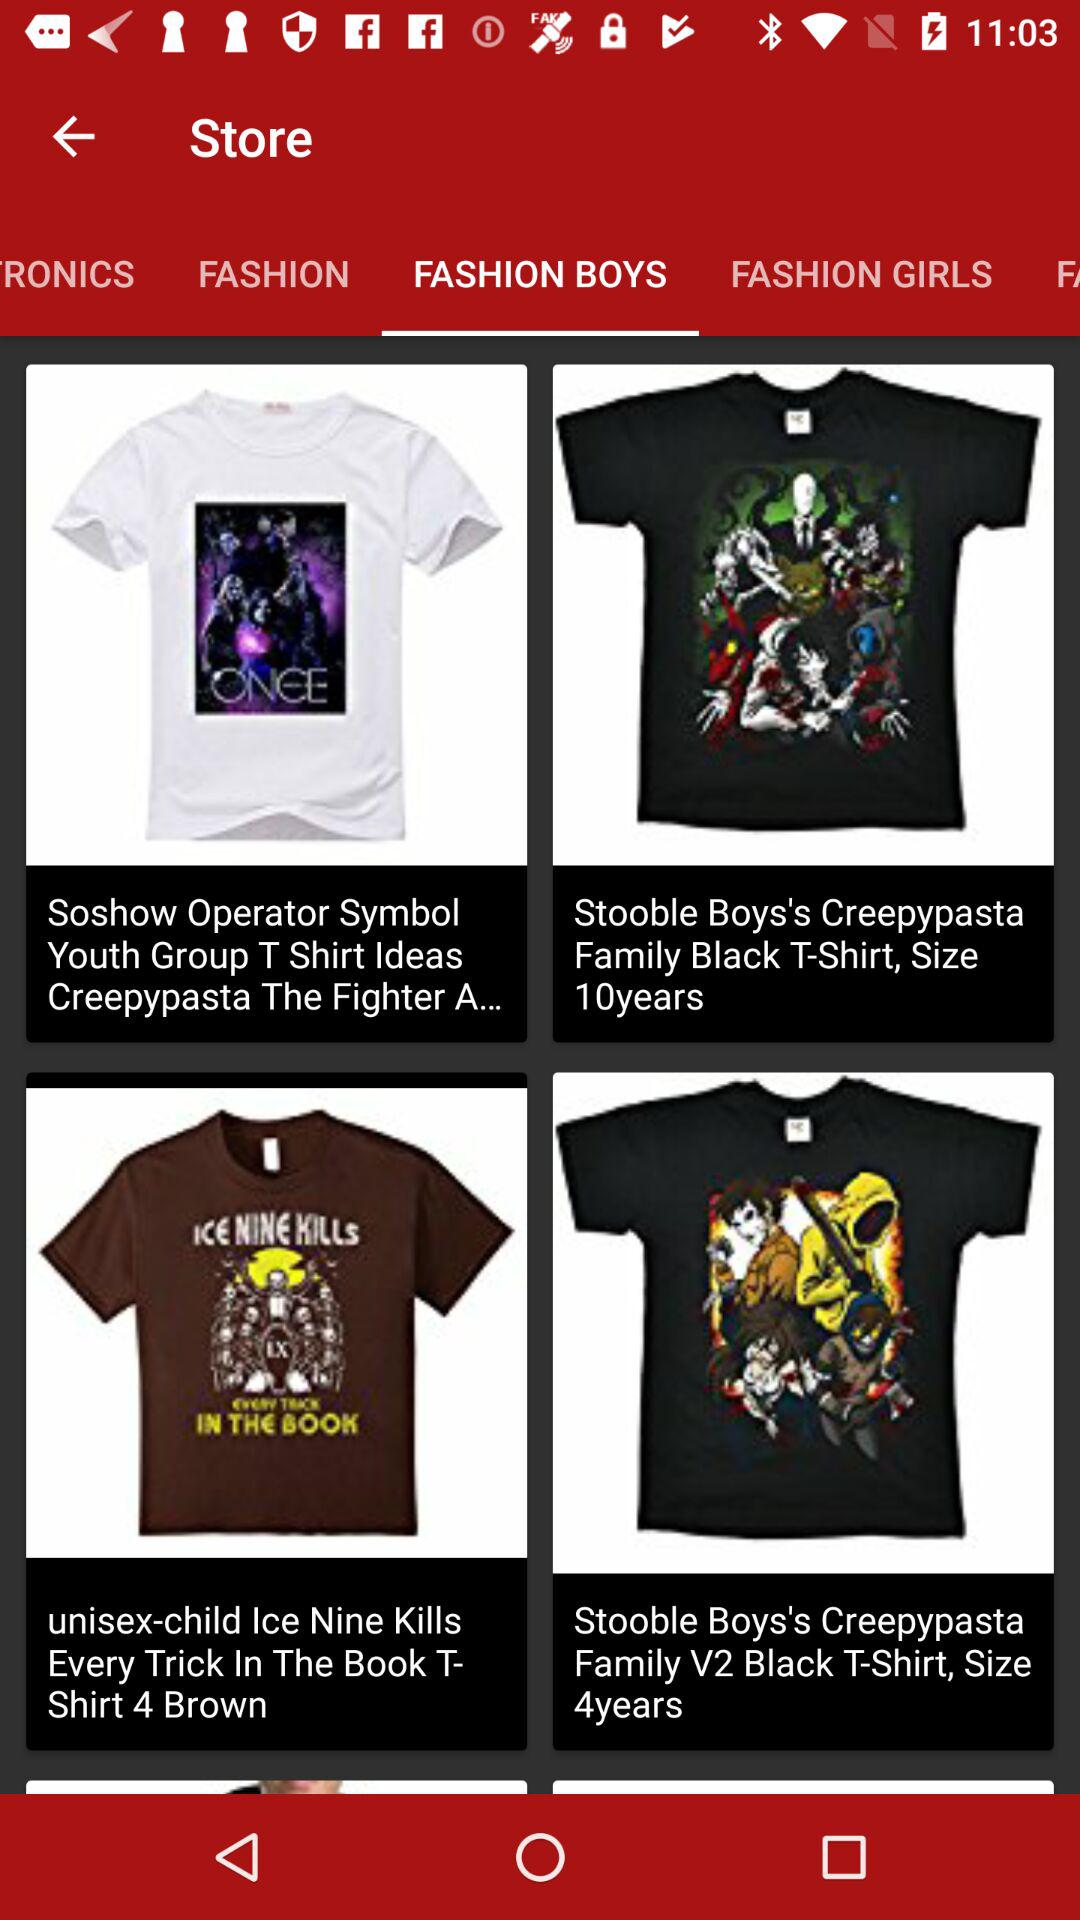Which category are we currently in? You are currently in the "FASHION BOYS" category. 